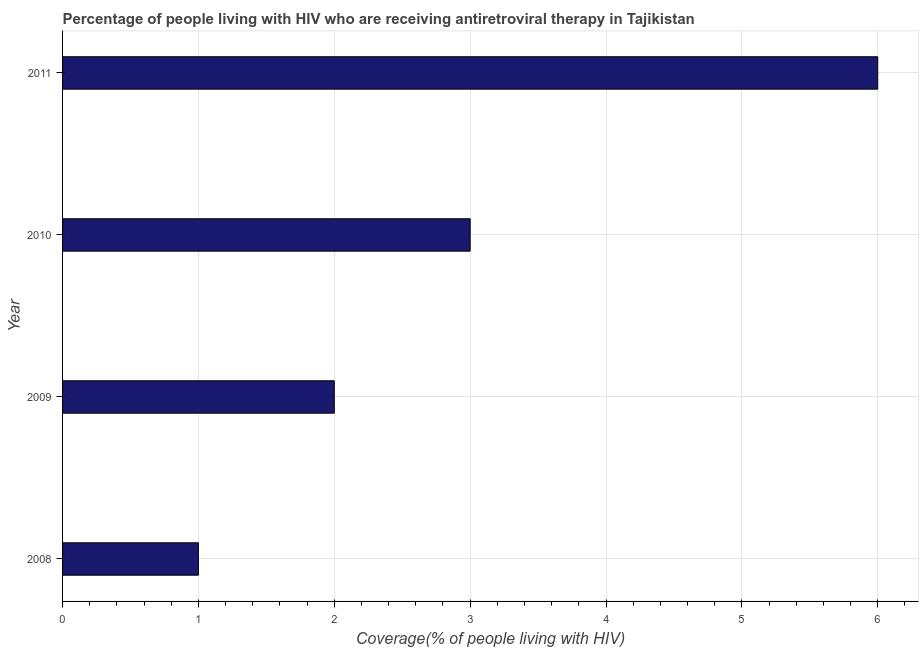Does the graph contain any zero values?
Ensure brevity in your answer.  No. Does the graph contain grids?
Offer a terse response. Yes. What is the title of the graph?
Your answer should be compact. Percentage of people living with HIV who are receiving antiretroviral therapy in Tajikistan. What is the label or title of the X-axis?
Make the answer very short. Coverage(% of people living with HIV). What is the label or title of the Y-axis?
Provide a succinct answer. Year. Across all years, what is the minimum antiretroviral therapy coverage?
Provide a short and direct response. 1. In which year was the antiretroviral therapy coverage maximum?
Ensure brevity in your answer.  2011. In which year was the antiretroviral therapy coverage minimum?
Keep it short and to the point. 2008. What is the average antiretroviral therapy coverage per year?
Your answer should be very brief. 3. Do a majority of the years between 2008 and 2009 (inclusive) have antiretroviral therapy coverage greater than 3.4 %?
Make the answer very short. No. What is the ratio of the antiretroviral therapy coverage in 2008 to that in 2010?
Provide a succinct answer. 0.33. What is the difference between the highest and the lowest antiretroviral therapy coverage?
Offer a terse response. 5. Are all the bars in the graph horizontal?
Your response must be concise. Yes. What is the difference between the Coverage(% of people living with HIV) in 2008 and 2010?
Your answer should be very brief. -2. What is the difference between the Coverage(% of people living with HIV) in 2009 and 2010?
Offer a terse response. -1. What is the difference between the Coverage(% of people living with HIV) in 2009 and 2011?
Your answer should be compact. -4. What is the difference between the Coverage(% of people living with HIV) in 2010 and 2011?
Your answer should be very brief. -3. What is the ratio of the Coverage(% of people living with HIV) in 2008 to that in 2010?
Your answer should be very brief. 0.33. What is the ratio of the Coverage(% of people living with HIV) in 2008 to that in 2011?
Make the answer very short. 0.17. What is the ratio of the Coverage(% of people living with HIV) in 2009 to that in 2010?
Give a very brief answer. 0.67. What is the ratio of the Coverage(% of people living with HIV) in 2009 to that in 2011?
Offer a very short reply. 0.33. What is the ratio of the Coverage(% of people living with HIV) in 2010 to that in 2011?
Your response must be concise. 0.5. 